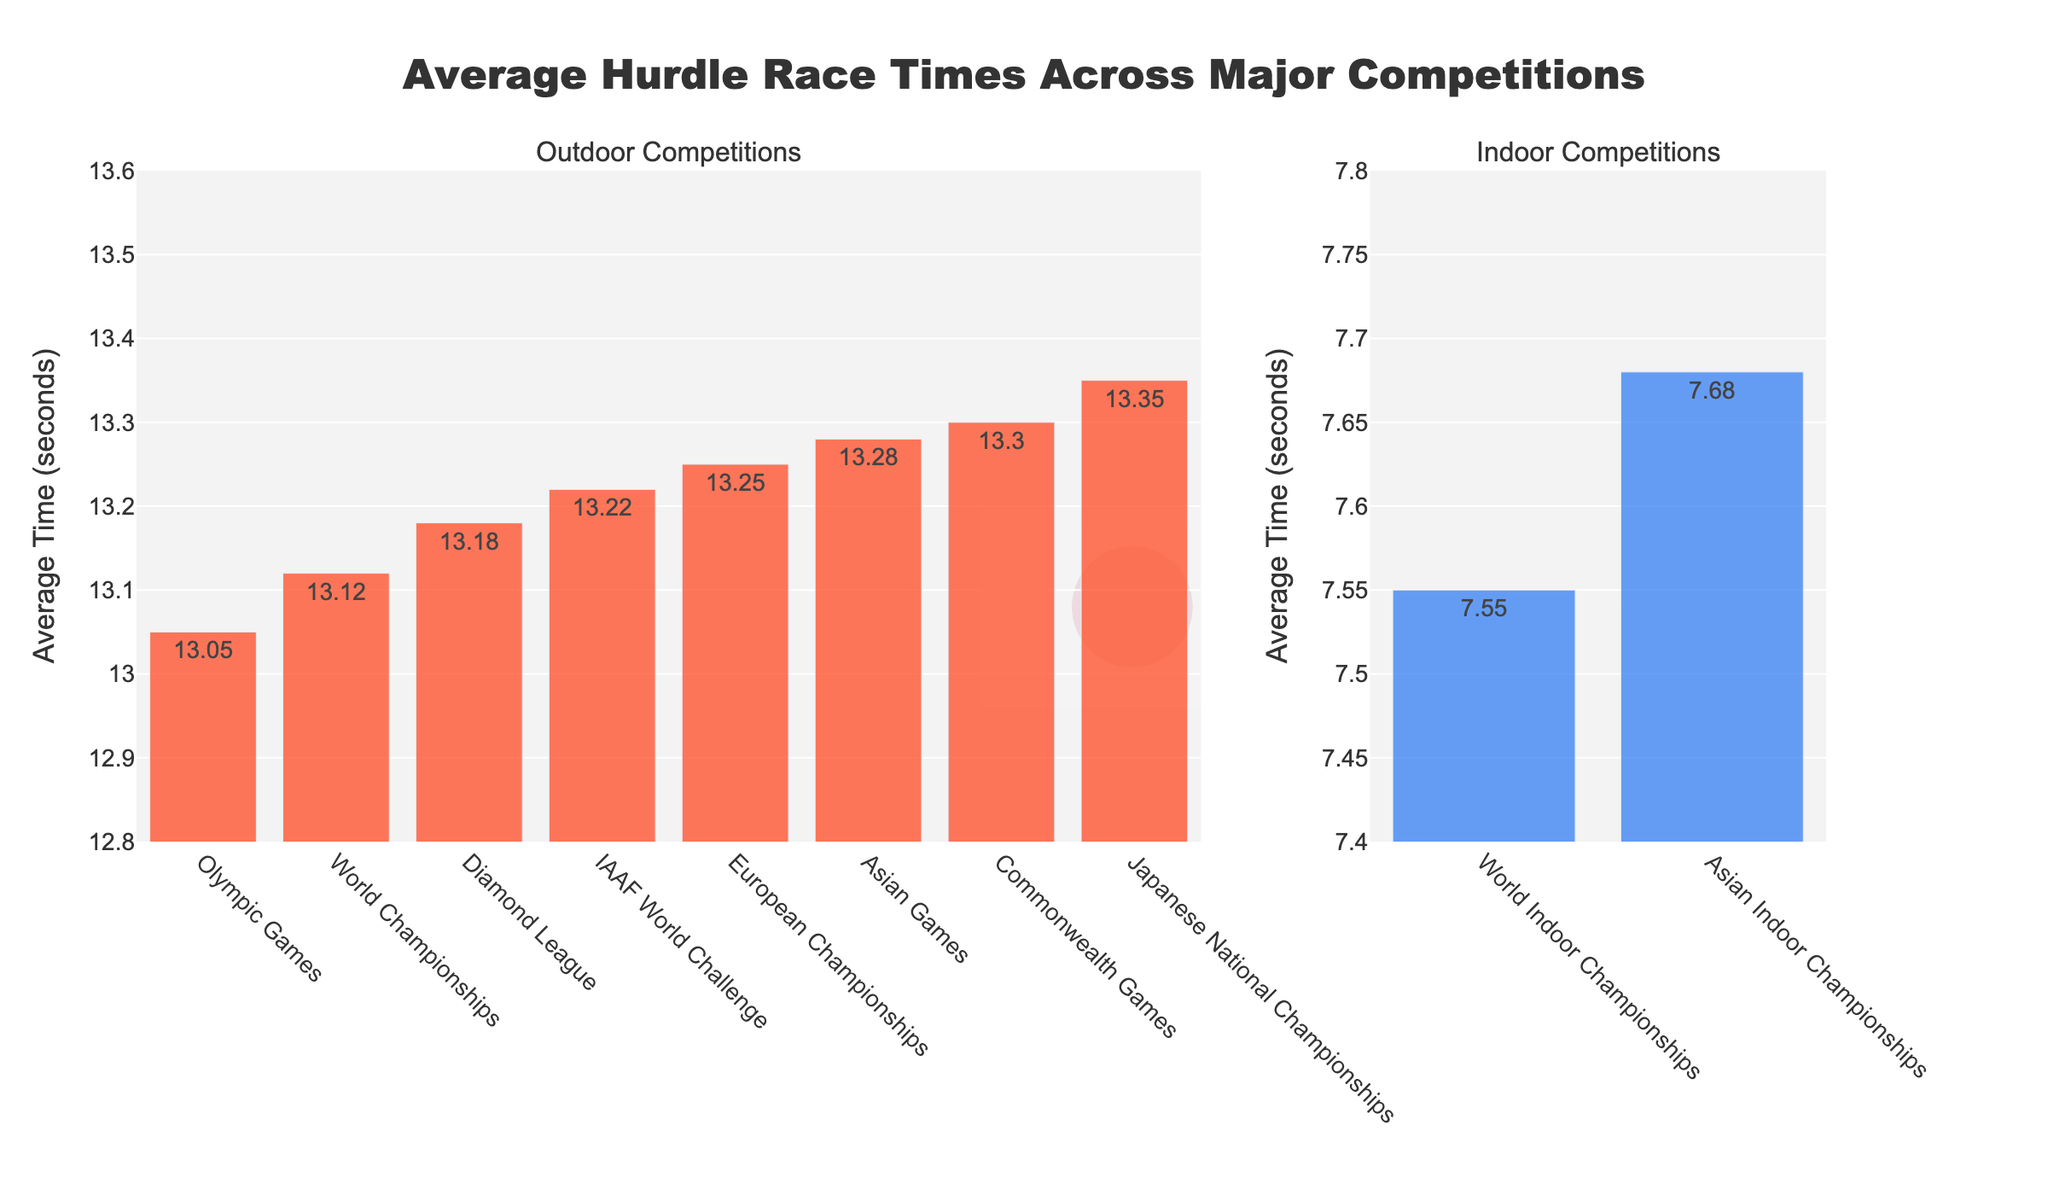what is the difference between the average time for the Olympic Games and the World Championships? The average time for the Olympic Games is 13.05 seconds, and for the World Championships, it is 13.12 seconds. The difference is 13.12 - 13.05 = 0.07 seconds.
Answer: 0.07 seconds Which competition has the slowest average time for outdoor hurdle races? The bar for the Japanese National Championships is the highest among the outdoor competitions, indicating the slowest average time. The average time is 13.35 seconds.
Answer: Japanese National Championships What are the two competitions with the fastest average times, one indoor and one outdoor? The World Indoor Championships has the fastest average time for indoor competitions with 7.55 seconds. The Olympic Games has the fastest average time for outdoor competitions with 13.05 seconds.
Answer: World Indoor Championships and Olympic Games How much faster is the average time in the World Indoor Championships compared to the Asian Indoor Championships? The average time for the World Indoor Championships is 7.55 seconds, and for the Asian Indoor Championships, it is 7.68 seconds. The difference is 7.68 - 7.55 = 0.13 seconds.
Answer: 0.13 seconds Compare the average times of the Diamond League and IAAF World Challenge. Which is faster and by how much? The average time for the Diamond League is 13.18 seconds, and for the IAAF World Challenge, it is 13.22 seconds. The Diamond League is faster by 13.22 - 13.18 = 0.04 seconds.
Answer: Diamond League, 0.04 seconds What is the average time difference between the Asian Games and the European Championships? The average time for the Asian Games is 13.28 seconds and for the European Championships is 13.25 seconds. The difference is 13.28 - 13.25 = 0.03 seconds.
Answer: 0.03 seconds Which has a higher average time, the Commonwealth Games or the Japanese National Championships? The bar for the Japanese National Championships is higher than that for the Commonwealth Games, indicating a higher average time of 13.35 seconds compared to 13.30 seconds for the Commonwealth Games.
Answer: Japanese National Championships What is the range of average times for outdoor competitions? The lowest average time for outdoor competitions is 13.05 seconds (Olympic Games) and the highest is 13.35 seconds (Japanese National Championships), so the range is 13.35 - 13.05 = 0.30 seconds.
Answer: 0.30 seconds How does the average time of the World Championships compare to the average time of the European Championships? The average time for the World Championships is 13.12 seconds, while for the European Championships it is 13.25 seconds. The World Championships have a faster average time by 13.25 - 13.12 = 0.13 seconds.
Answer: World Championships is faster by 0.13 seconds 